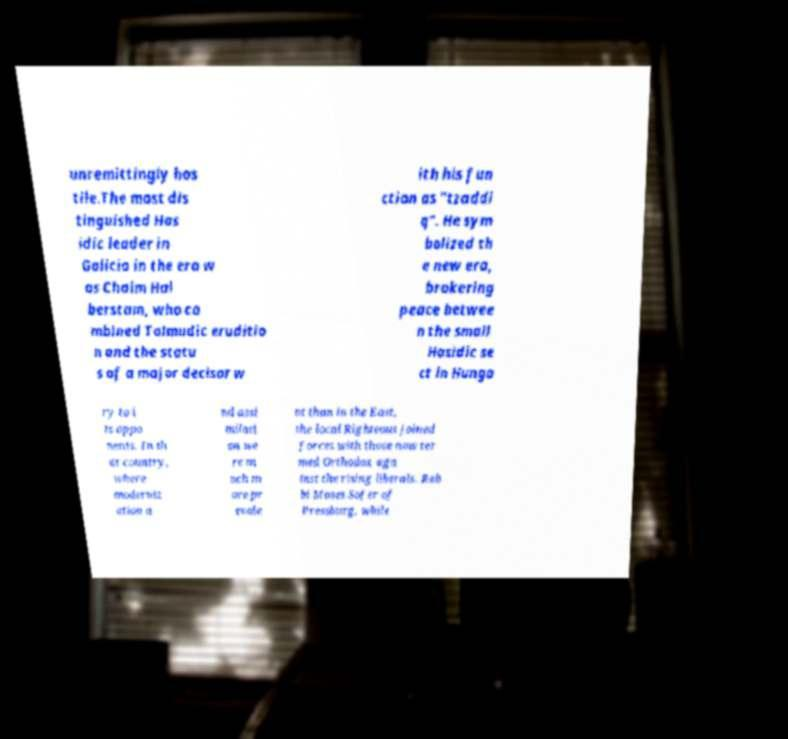Could you assist in decoding the text presented in this image and type it out clearly? unremittingly hos tile.The most dis tinguished Has idic leader in Galicia in the era w as Chaim Hal berstam, who co mbined Talmudic eruditio n and the statu s of a major decisor w ith his fun ction as "tzaddi q". He sym bolized th e new era, brokering peace betwee n the small Hasidic se ct in Hunga ry to i ts oppo nents. In th at country, where moderniz ation a nd assi milati on we re m uch m ore pr evale nt than in the East, the local Righteous joined forces with those now ter med Orthodox aga inst the rising liberals. Rab bi Moses Sofer of Pressburg, while 